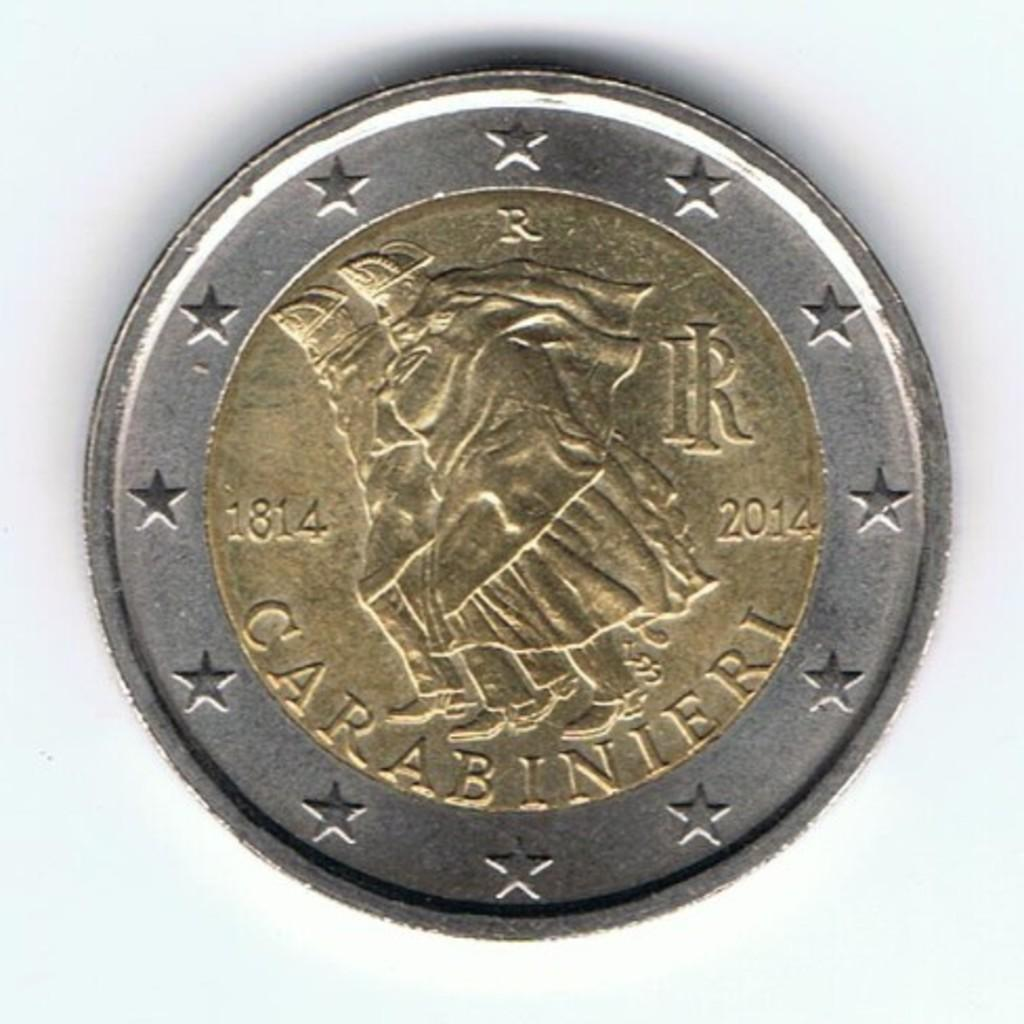<image>
Describe the image concisely. a coin that was made from 1814 to 2014 